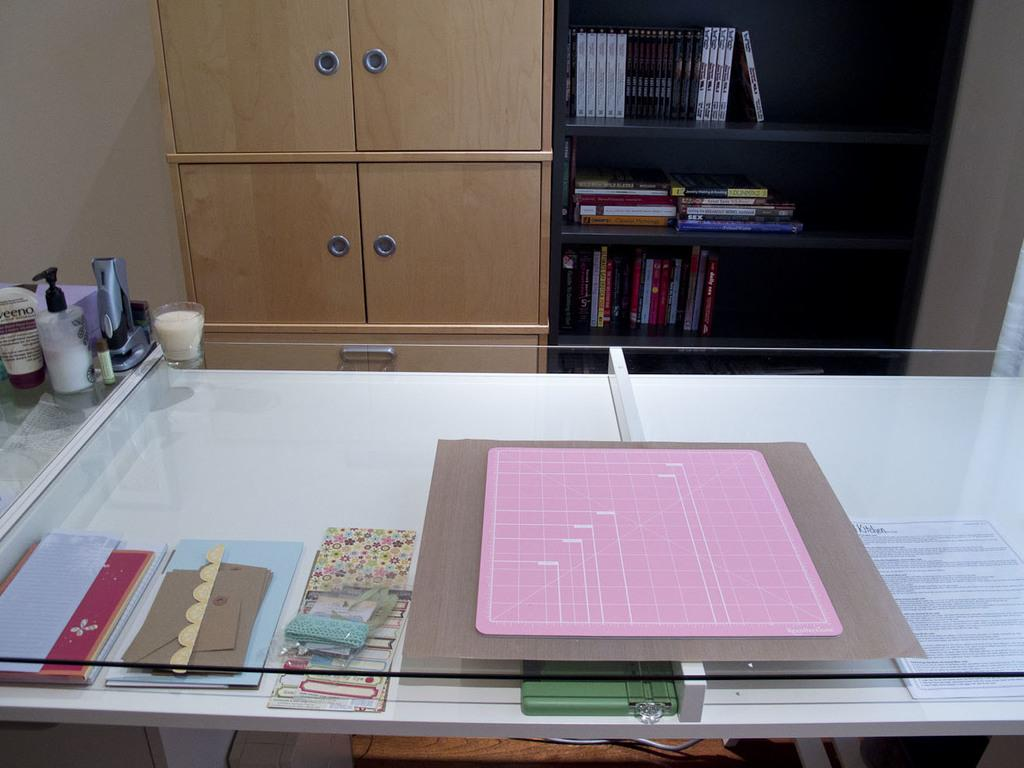What type of space is depicted in the image? There is a room in the image. What type of furniture can be seen in the room? There are cupboards and tables in the room. What is placed on the tables in the room? There are different items present on the tables. How many cherries are on the son's plate in the image? There is no son or plate with cherries present in the image. 